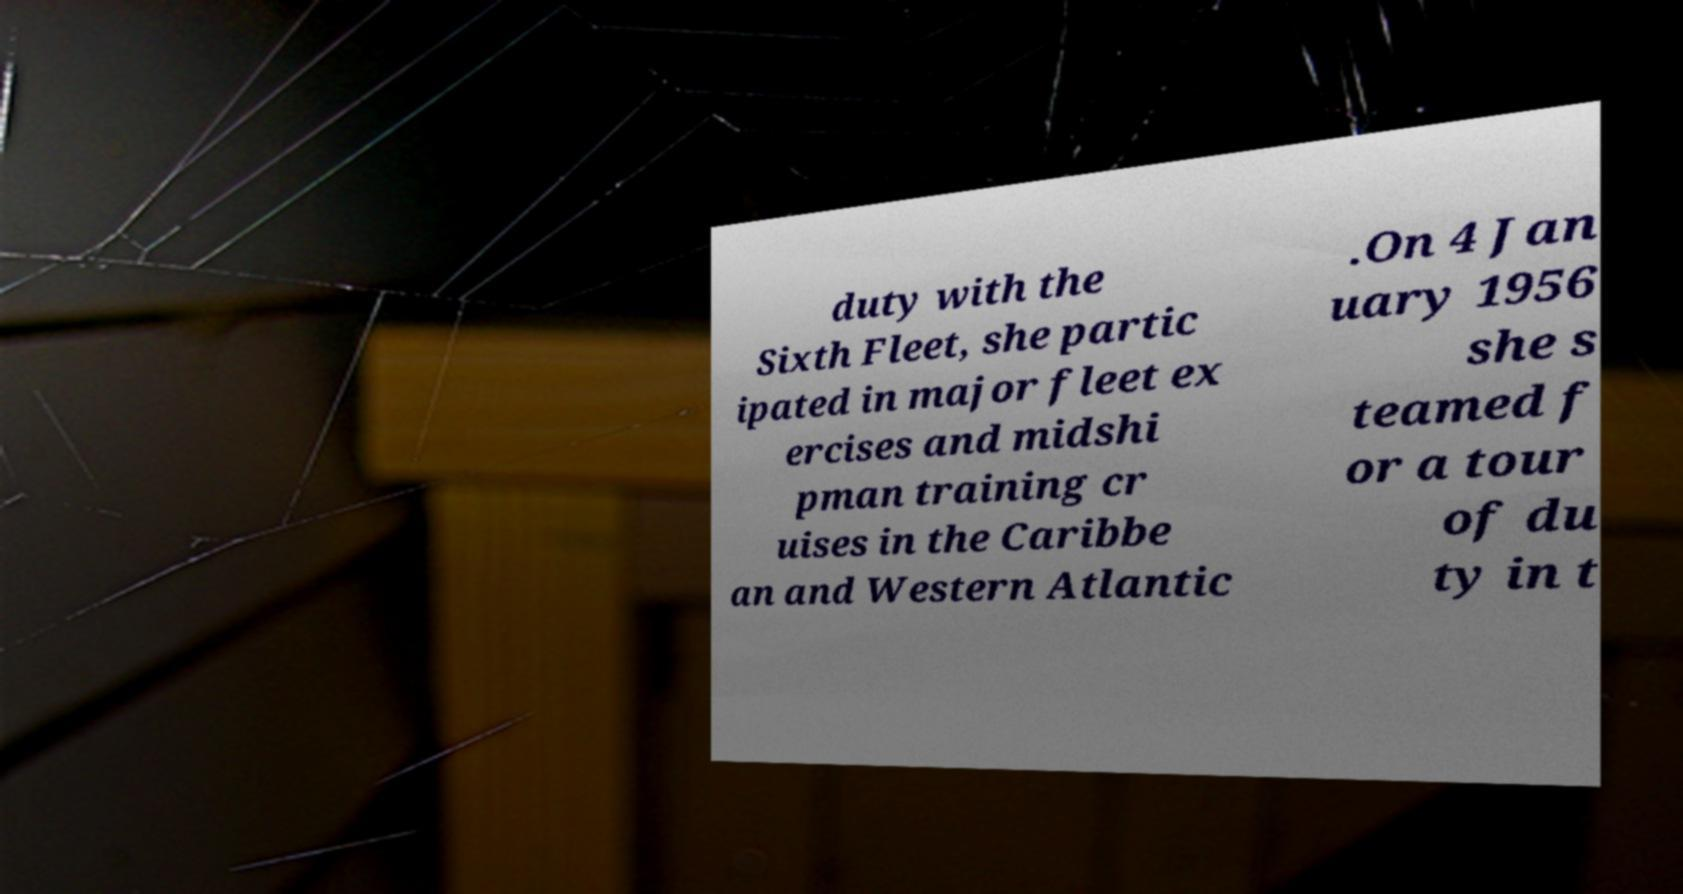Can you read and provide the text displayed in the image?This photo seems to have some interesting text. Can you extract and type it out for me? duty with the Sixth Fleet, she partic ipated in major fleet ex ercises and midshi pman training cr uises in the Caribbe an and Western Atlantic .On 4 Jan uary 1956 she s teamed f or a tour of du ty in t 